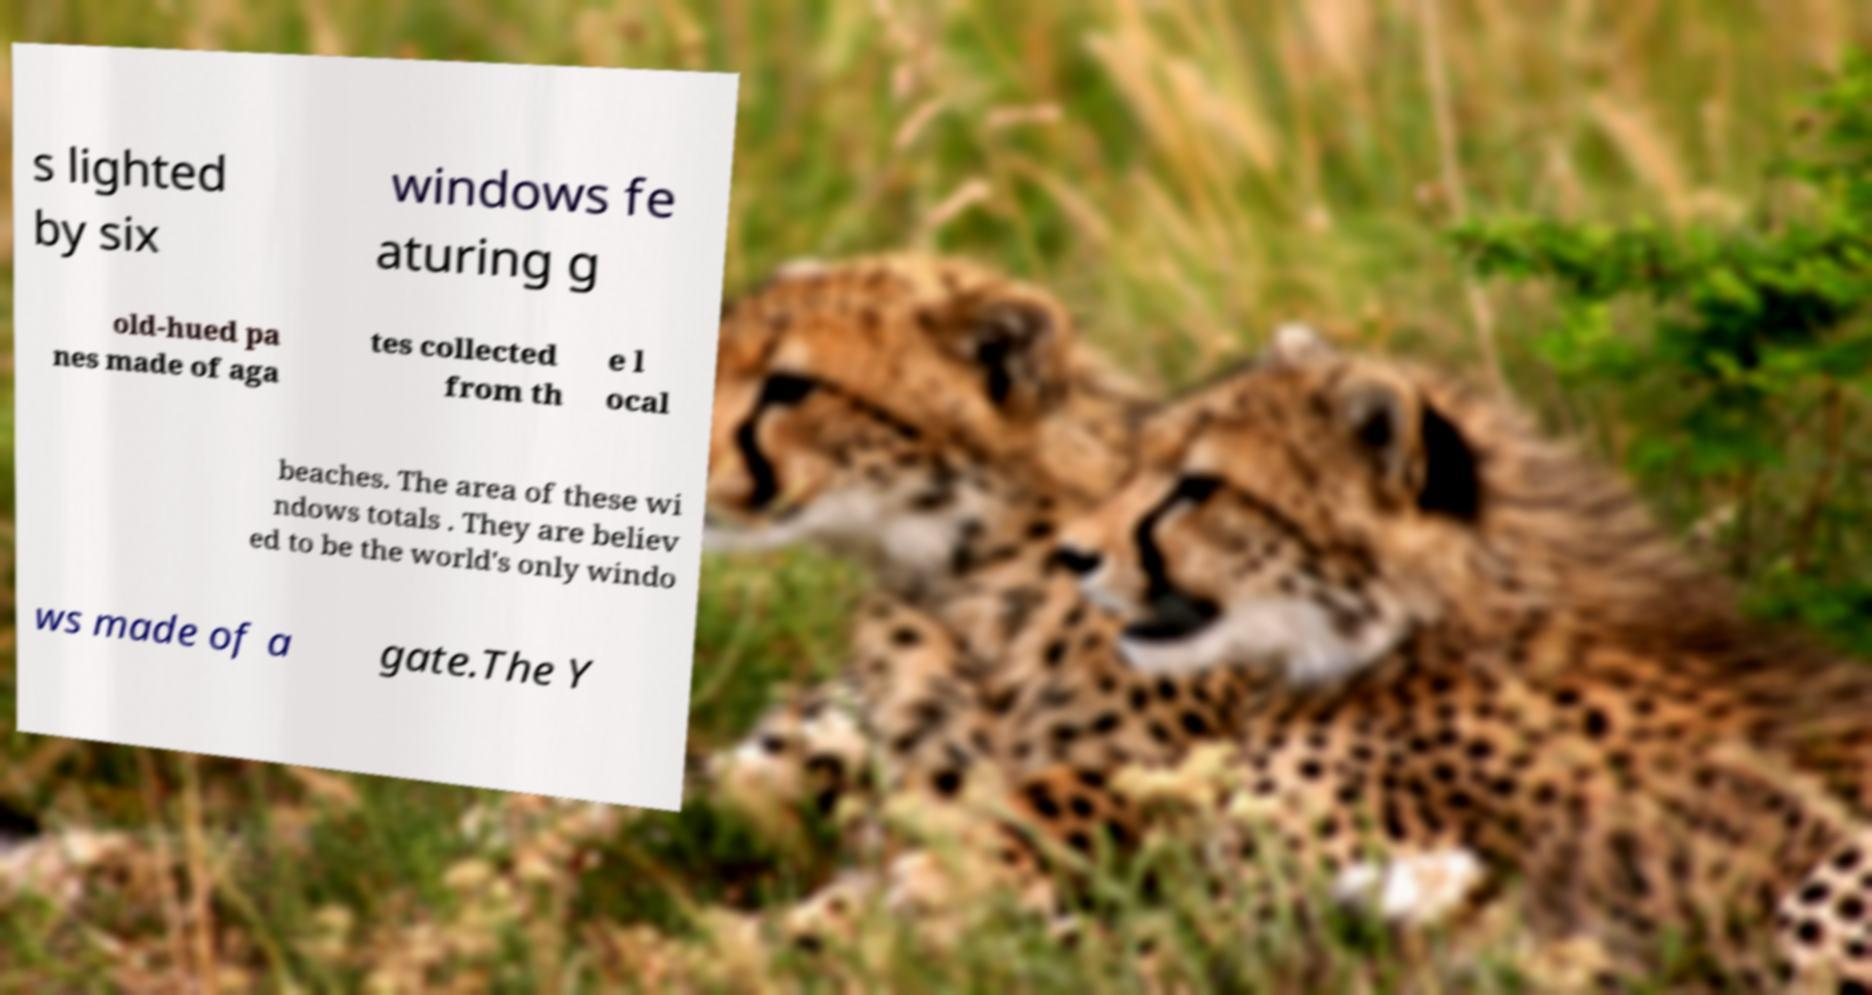Could you assist in decoding the text presented in this image and type it out clearly? s lighted by six windows fe aturing g old-hued pa nes made of aga tes collected from th e l ocal beaches. The area of these wi ndows totals . They are believ ed to be the world's only windo ws made of a gate.The Y 